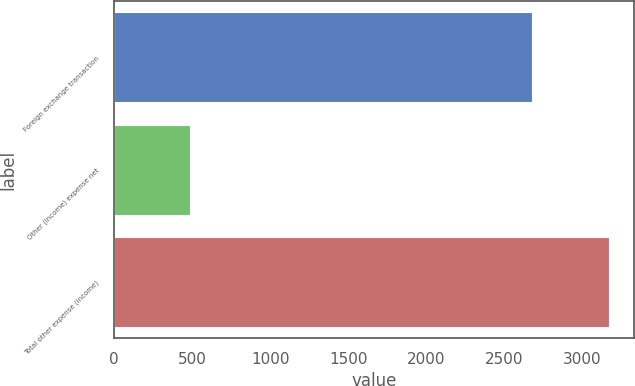<chart> <loc_0><loc_0><loc_500><loc_500><bar_chart><fcel>Foreign exchange transaction<fcel>Other (income) expense net<fcel>Total other expense (income)<nl><fcel>2679<fcel>490<fcel>3169<nl></chart> 